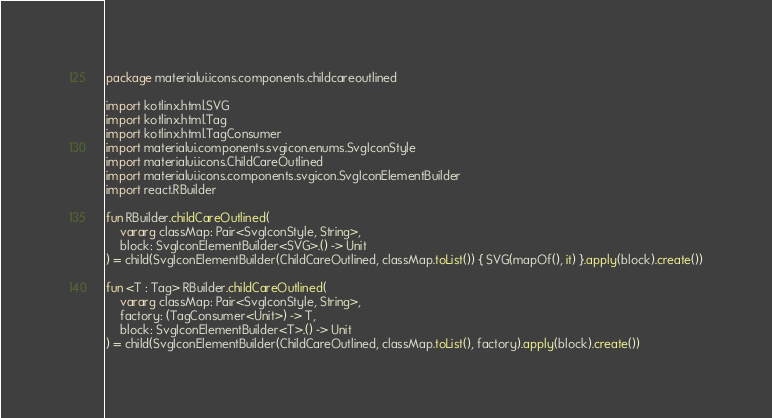Convert code to text. <code><loc_0><loc_0><loc_500><loc_500><_Kotlin_>package materialui.icons.components.childcareoutlined

import kotlinx.html.SVG
import kotlinx.html.Tag
import kotlinx.html.TagConsumer
import materialui.components.svgicon.enums.SvgIconStyle
import materialui.icons.ChildCareOutlined
import materialui.icons.components.svgicon.SvgIconElementBuilder
import react.RBuilder

fun RBuilder.childCareOutlined(
    vararg classMap: Pair<SvgIconStyle, String>,
    block: SvgIconElementBuilder<SVG>.() -> Unit
) = child(SvgIconElementBuilder(ChildCareOutlined, classMap.toList()) { SVG(mapOf(), it) }.apply(block).create())

fun <T : Tag> RBuilder.childCareOutlined(
    vararg classMap: Pair<SvgIconStyle, String>,
    factory: (TagConsumer<Unit>) -> T,
    block: SvgIconElementBuilder<T>.() -> Unit
) = child(SvgIconElementBuilder(ChildCareOutlined, classMap.toList(), factory).apply(block).create())
</code> 